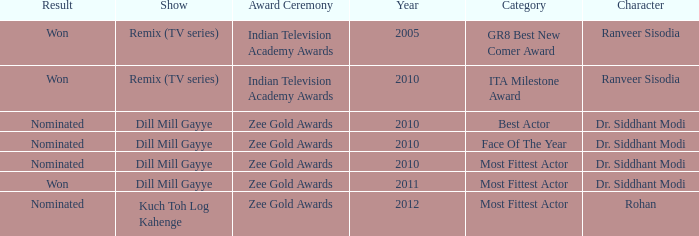Which show was nominated for the ITA Milestone Award at the Indian Television Academy Awards? Remix (TV series). 